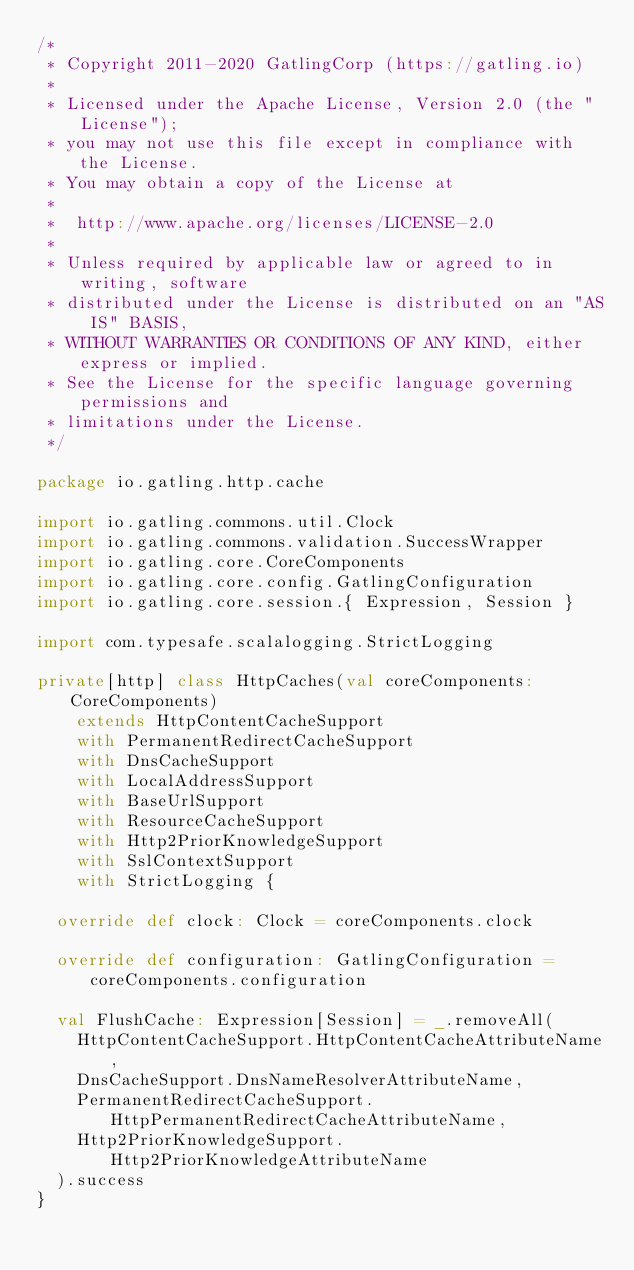<code> <loc_0><loc_0><loc_500><loc_500><_Scala_>/*
 * Copyright 2011-2020 GatlingCorp (https://gatling.io)
 *
 * Licensed under the Apache License, Version 2.0 (the "License");
 * you may not use this file except in compliance with the License.
 * You may obtain a copy of the License at
 *
 *  http://www.apache.org/licenses/LICENSE-2.0
 *
 * Unless required by applicable law or agreed to in writing, software
 * distributed under the License is distributed on an "AS IS" BASIS,
 * WITHOUT WARRANTIES OR CONDITIONS OF ANY KIND, either express or implied.
 * See the License for the specific language governing permissions and
 * limitations under the License.
 */

package io.gatling.http.cache

import io.gatling.commons.util.Clock
import io.gatling.commons.validation.SuccessWrapper
import io.gatling.core.CoreComponents
import io.gatling.core.config.GatlingConfiguration
import io.gatling.core.session.{ Expression, Session }

import com.typesafe.scalalogging.StrictLogging

private[http] class HttpCaches(val coreComponents: CoreComponents)
    extends HttpContentCacheSupport
    with PermanentRedirectCacheSupport
    with DnsCacheSupport
    with LocalAddressSupport
    with BaseUrlSupport
    with ResourceCacheSupport
    with Http2PriorKnowledgeSupport
    with SslContextSupport
    with StrictLogging {

  override def clock: Clock = coreComponents.clock

  override def configuration: GatlingConfiguration = coreComponents.configuration

  val FlushCache: Expression[Session] = _.removeAll(
    HttpContentCacheSupport.HttpContentCacheAttributeName,
    DnsCacheSupport.DnsNameResolverAttributeName,
    PermanentRedirectCacheSupport.HttpPermanentRedirectCacheAttributeName,
    Http2PriorKnowledgeSupport.Http2PriorKnowledgeAttributeName
  ).success
}
</code> 